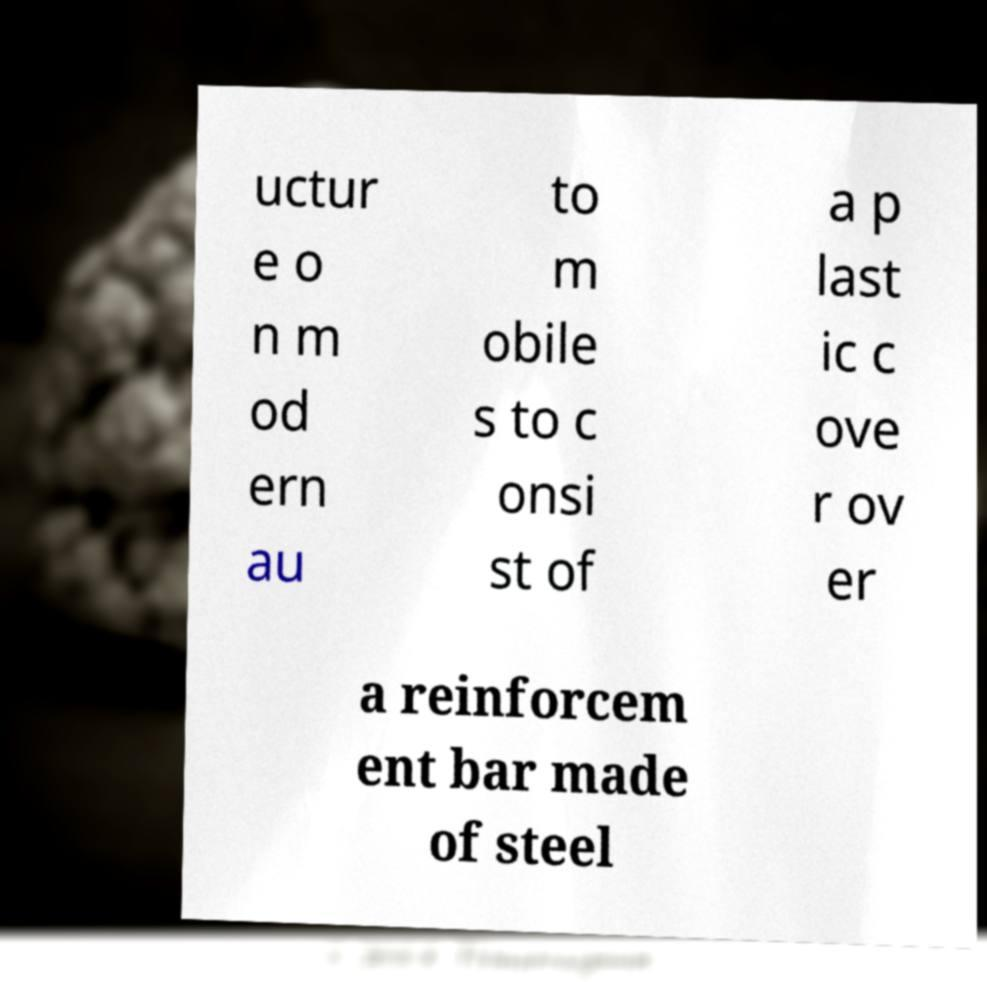Could you extract and type out the text from this image? uctur e o n m od ern au to m obile s to c onsi st of a p last ic c ove r ov er a reinforcem ent bar made of steel 